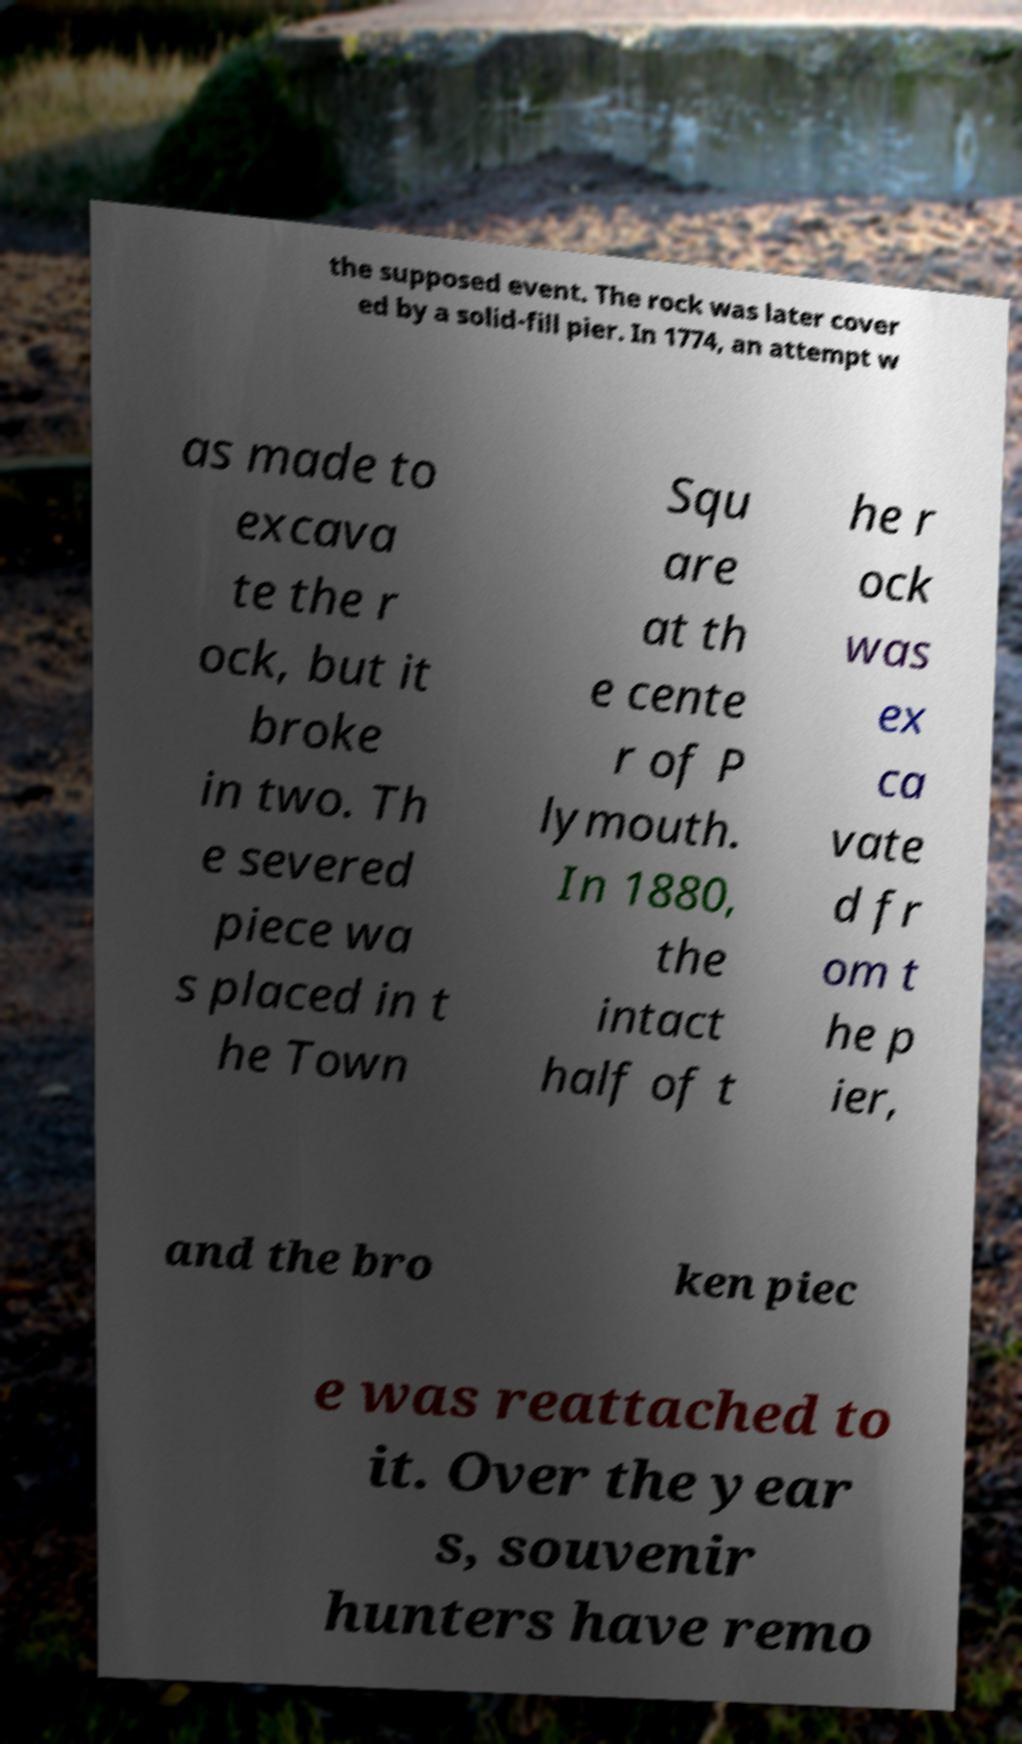Can you accurately transcribe the text from the provided image for me? the supposed event. The rock was later cover ed by a solid-fill pier. In 1774, an attempt w as made to excava te the r ock, but it broke in two. Th e severed piece wa s placed in t he Town Squ are at th e cente r of P lymouth. In 1880, the intact half of t he r ock was ex ca vate d fr om t he p ier, and the bro ken piec e was reattached to it. Over the year s, souvenir hunters have remo 